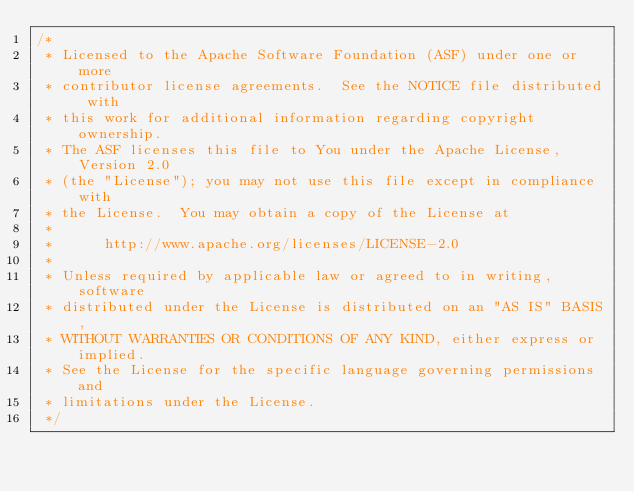<code> <loc_0><loc_0><loc_500><loc_500><_Java_>/*
 * Licensed to the Apache Software Foundation (ASF) under one or more
 * contributor license agreements.  See the NOTICE file distributed with
 * this work for additional information regarding copyright ownership.
 * The ASF licenses this file to You under the Apache License, Version 2.0
 * (the "License"); you may not use this file except in compliance with
 * the License.  You may obtain a copy of the License at
 *
 *      http://www.apache.org/licenses/LICENSE-2.0
 *
 * Unless required by applicable law or agreed to in writing, software
 * distributed under the License is distributed on an "AS IS" BASIS,
 * WITHOUT WARRANTIES OR CONDITIONS OF ANY KIND, either express or implied.
 * See the License for the specific language governing permissions and
 * limitations under the License.
 */</code> 